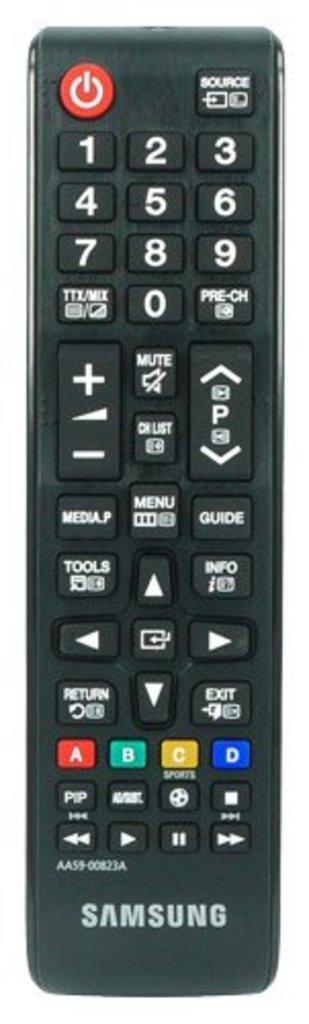Does samsung use a universal remote?
Keep it short and to the point. Yes. What model of samsung can the remote be used for?
Your answer should be very brief. Aa59-00823a. 